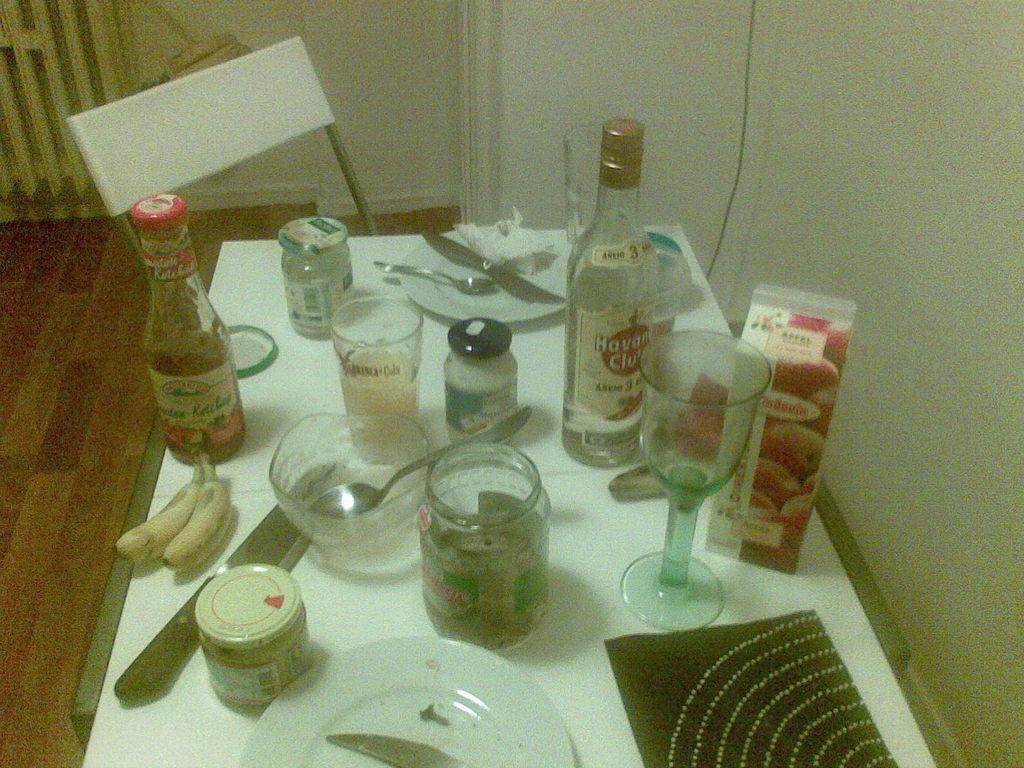Describe this image in one or two sentences. In this image I can see a chair, few bottles and glasses on this table. I can also see a plate, knife and a spoon. 